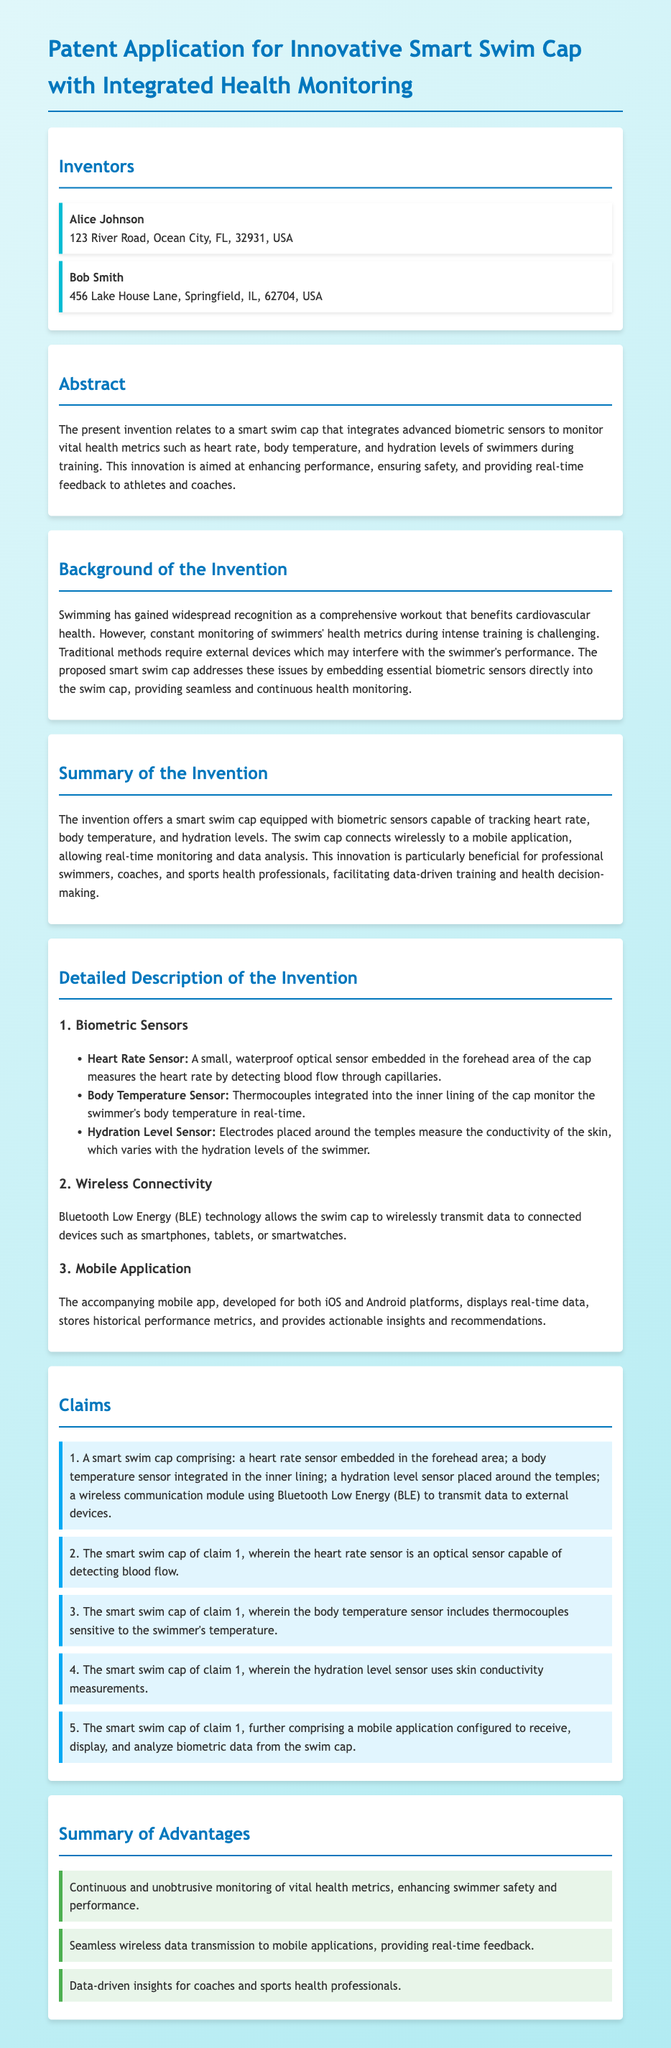What is the title of the patent application? The title is stated at the beginning of the document.
Answer: Smart Swim Cap Patent Application Who are the inventors listed in the document? Inventors are listed in the section titled "Inventors."
Answer: Alice Johnson, Bob Smith What health metrics does the swim cap monitor? This information can be found in the "Abstract" and "Summary of the Invention" sections.
Answer: Heart rate, body temperature, hydration levels What technology does the swim cap use for wireless data transmission? This information is detailed in the "Wireless Connectivity" section.
Answer: Bluetooth Low Energy (BLE) What is the purpose of the mobile application associated with the swim cap? The relevance of the mobile application is mentioned in the "Mobile Application" section.
Answer: Display real-time data What is claim 1 of the patent application about? Claim 1 is summarized in the "Claims" section of the document.
Answer: A smart swim cap comprising biometric sensors and wireless communication Why is the smart swim cap considered beneficial for athletes? This reasoning can be found in the "Summary of Advantages" section explaining its benefits.
Answer: Enhances swimmer safety and performance Which inventor lives in Ocean City, FL? The specific information about locations is given in the "Inventors" section.
Answer: Alice Johnson 